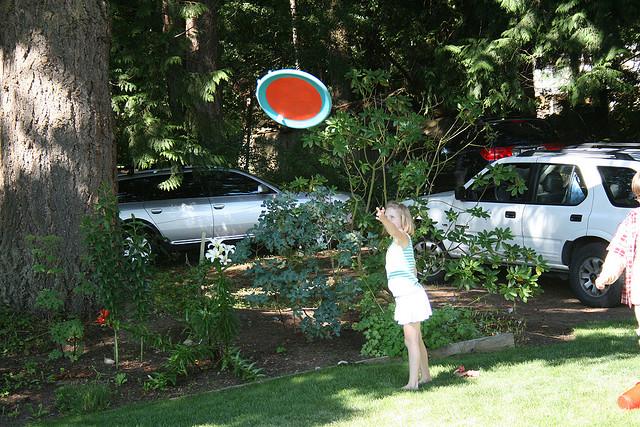Is the girl in the garden?
Short answer required. No. Is the little girl wearing a summer dress?
Write a very short answer. Yes. What style of vehicle is that?
Short answer required. Suv. 